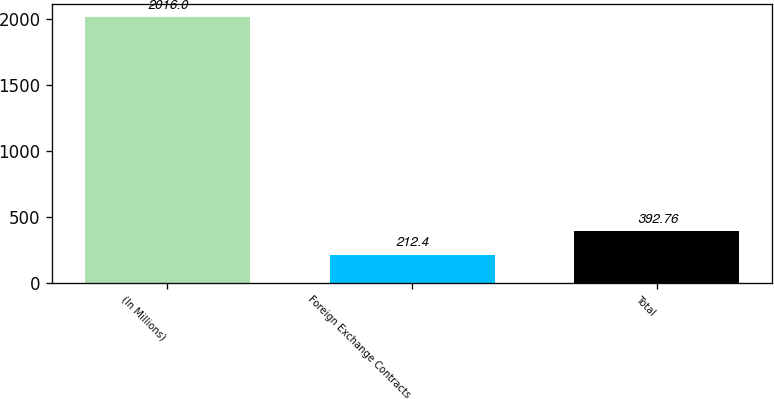Convert chart. <chart><loc_0><loc_0><loc_500><loc_500><bar_chart><fcel>(In Millions)<fcel>Foreign Exchange Contracts<fcel>Total<nl><fcel>2016<fcel>212.4<fcel>392.76<nl></chart> 